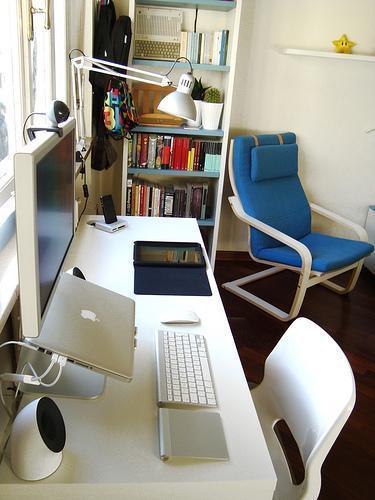How many chairs are there?
Give a very brief answer. 2. How many computers are on the desk?
Give a very brief answer. 1. How many chairs are in the scene?
Give a very brief answer. 2. 